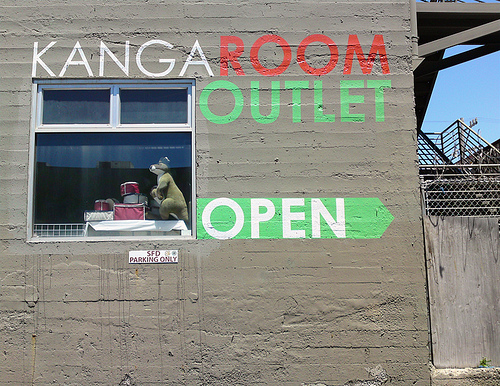<image>
Is there a open sign in the window? No. The open sign is not contained within the window. These objects have a different spatial relationship. 